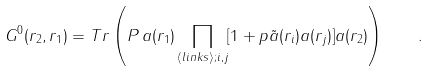<formula> <loc_0><loc_0><loc_500><loc_500>G ^ { 0 } ( { r } _ { 2 } , { r } _ { 1 } ) = T r \left ( P \, a ( { r } _ { 1 } ) \prod _ { \langle l i n k s \rangle ; i , j } [ 1 + p { \tilde { a } } ( { r } _ { i } ) a ( { r } _ { j } ) ] a ( { r } _ { 2 } ) \right ) \quad .</formula> 